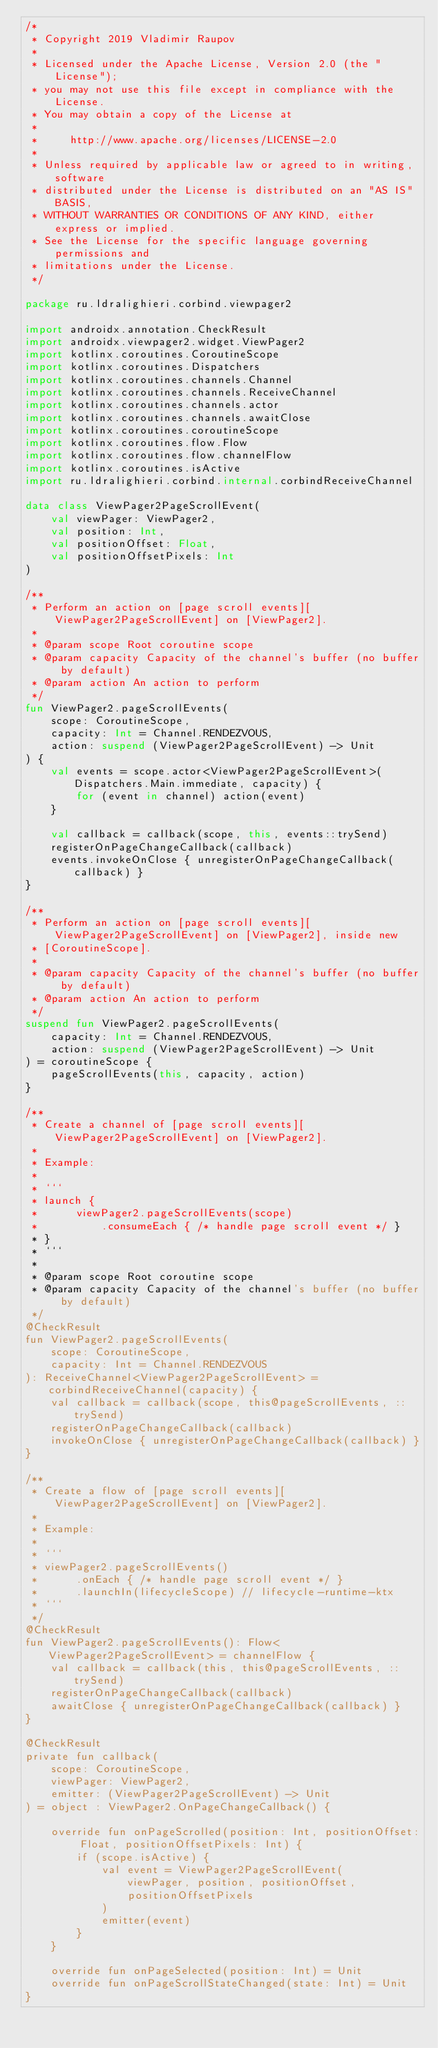Convert code to text. <code><loc_0><loc_0><loc_500><loc_500><_Kotlin_>/*
 * Copyright 2019 Vladimir Raupov
 *
 * Licensed under the Apache License, Version 2.0 (the "License");
 * you may not use this file except in compliance with the License.
 * You may obtain a copy of the License at
 *
 *     http://www.apache.org/licenses/LICENSE-2.0
 *
 * Unless required by applicable law or agreed to in writing, software
 * distributed under the License is distributed on an "AS IS" BASIS,
 * WITHOUT WARRANTIES OR CONDITIONS OF ANY KIND, either express or implied.
 * See the License for the specific language governing permissions and
 * limitations under the License.
 */

package ru.ldralighieri.corbind.viewpager2

import androidx.annotation.CheckResult
import androidx.viewpager2.widget.ViewPager2
import kotlinx.coroutines.CoroutineScope
import kotlinx.coroutines.Dispatchers
import kotlinx.coroutines.channels.Channel
import kotlinx.coroutines.channels.ReceiveChannel
import kotlinx.coroutines.channels.actor
import kotlinx.coroutines.channels.awaitClose
import kotlinx.coroutines.coroutineScope
import kotlinx.coroutines.flow.Flow
import kotlinx.coroutines.flow.channelFlow
import kotlinx.coroutines.isActive
import ru.ldralighieri.corbind.internal.corbindReceiveChannel

data class ViewPager2PageScrollEvent(
    val viewPager: ViewPager2,
    val position: Int,
    val positionOffset: Float,
    val positionOffsetPixels: Int
)

/**
 * Perform an action on [page scroll events][ViewPager2PageScrollEvent] on [ViewPager2].
 *
 * @param scope Root coroutine scope
 * @param capacity Capacity of the channel's buffer (no buffer by default)
 * @param action An action to perform
 */
fun ViewPager2.pageScrollEvents(
    scope: CoroutineScope,
    capacity: Int = Channel.RENDEZVOUS,
    action: suspend (ViewPager2PageScrollEvent) -> Unit
) {
    val events = scope.actor<ViewPager2PageScrollEvent>(Dispatchers.Main.immediate, capacity) {
        for (event in channel) action(event)
    }

    val callback = callback(scope, this, events::trySend)
    registerOnPageChangeCallback(callback)
    events.invokeOnClose { unregisterOnPageChangeCallback(callback) }
}

/**
 * Perform an action on [page scroll events][ViewPager2PageScrollEvent] on [ViewPager2], inside new
 * [CoroutineScope].
 *
 * @param capacity Capacity of the channel's buffer (no buffer by default)
 * @param action An action to perform
 */
suspend fun ViewPager2.pageScrollEvents(
    capacity: Int = Channel.RENDEZVOUS,
    action: suspend (ViewPager2PageScrollEvent) -> Unit
) = coroutineScope {
    pageScrollEvents(this, capacity, action)
}

/**
 * Create a channel of [page scroll events][ViewPager2PageScrollEvent] on [ViewPager2].
 *
 * Example:
 *
 * ```
 * launch {
 *      viewPager2.pageScrollEvents(scope)
 *          .consumeEach { /* handle page scroll event */ }
 * }
 * ```
 *
 * @param scope Root coroutine scope
 * @param capacity Capacity of the channel's buffer (no buffer by default)
 */
@CheckResult
fun ViewPager2.pageScrollEvents(
    scope: CoroutineScope,
    capacity: Int = Channel.RENDEZVOUS
): ReceiveChannel<ViewPager2PageScrollEvent> = corbindReceiveChannel(capacity) {
    val callback = callback(scope, this@pageScrollEvents, ::trySend)
    registerOnPageChangeCallback(callback)
    invokeOnClose { unregisterOnPageChangeCallback(callback) }
}

/**
 * Create a flow of [page scroll events][ViewPager2PageScrollEvent] on [ViewPager2].
 *
 * Example:
 *
 * ```
 * viewPager2.pageScrollEvents()
 *      .onEach { /* handle page scroll event */ }
 *      .launchIn(lifecycleScope) // lifecycle-runtime-ktx
 * ```
 */
@CheckResult
fun ViewPager2.pageScrollEvents(): Flow<ViewPager2PageScrollEvent> = channelFlow {
    val callback = callback(this, this@pageScrollEvents, ::trySend)
    registerOnPageChangeCallback(callback)
    awaitClose { unregisterOnPageChangeCallback(callback) }
}

@CheckResult
private fun callback(
    scope: CoroutineScope,
    viewPager: ViewPager2,
    emitter: (ViewPager2PageScrollEvent) -> Unit
) = object : ViewPager2.OnPageChangeCallback() {

    override fun onPageScrolled(position: Int, positionOffset: Float, positionOffsetPixels: Int) {
        if (scope.isActive) {
            val event = ViewPager2PageScrollEvent(
                viewPager, position, positionOffset,
                positionOffsetPixels
            )
            emitter(event)
        }
    }

    override fun onPageSelected(position: Int) = Unit
    override fun onPageScrollStateChanged(state: Int) = Unit
}
</code> 